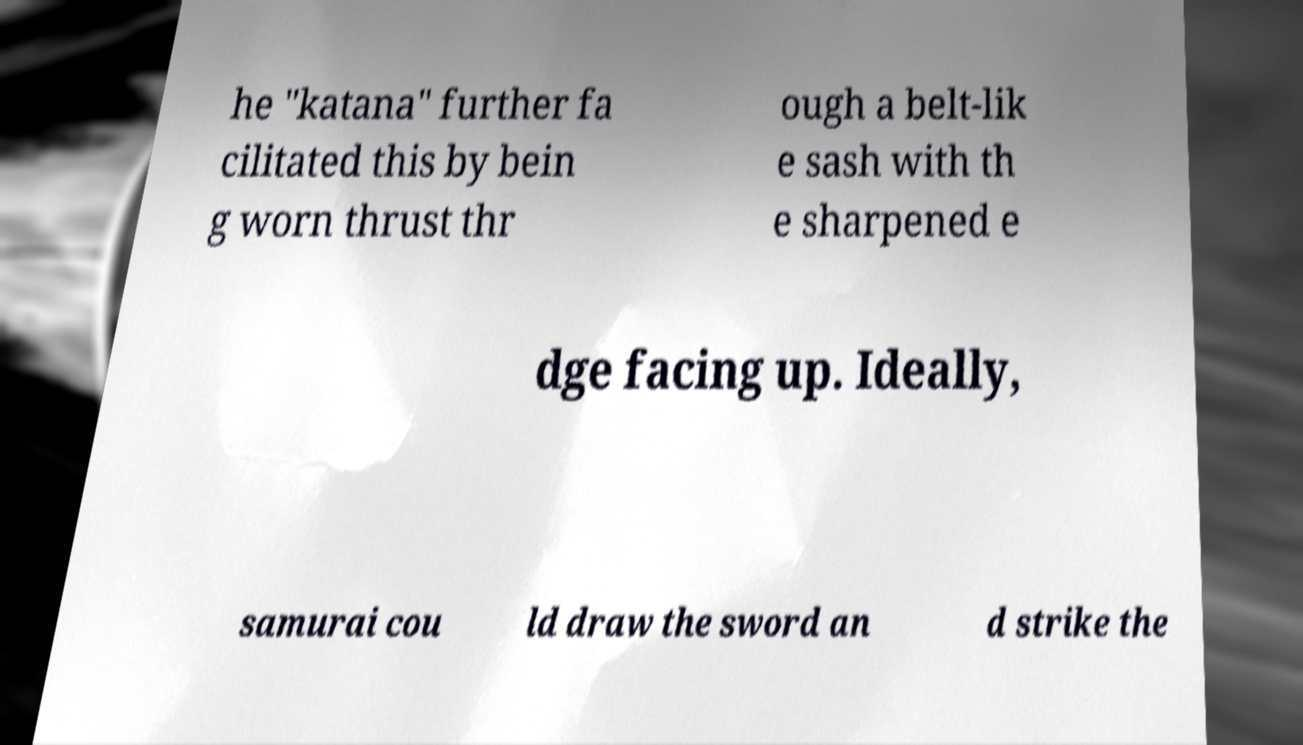Could you assist in decoding the text presented in this image and type it out clearly? he "katana" further fa cilitated this by bein g worn thrust thr ough a belt-lik e sash with th e sharpened e dge facing up. Ideally, samurai cou ld draw the sword an d strike the 